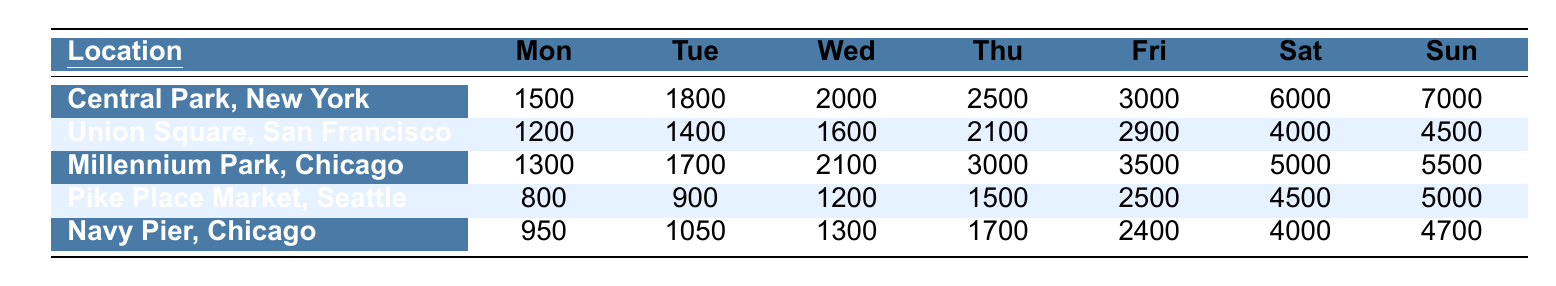What is the pedestrian traffic in Central Park on Saturday? The table shows that on Saturday, Central Park, New York has a pedestrian traffic of 6000.
Answer: 6000 Which location has the highest pedestrian traffic on Sunday? According to the table, Central Park, New York has the highest pedestrian traffic on Sunday with 7000.
Answer: Central Park, New York What is the average pedestrian traffic for Union Square, San Francisco during the week? To find the average, sum the daily values: 1200 + 1400 + 1600 + 2100 + 2900 + 4000 + 4500 = 19500. There are 7 days, so the average is 19500 / 7 = approximately 2786.
Answer: 2786 On which day does Pike Place Market, Seattle see the lowest pedestrian traffic? The table indicates that on Monday, Pike Place Market, Seattle has the lowest pedestrian traffic with only 800.
Answer: Monday What is the difference in pedestrian traffic between Millennium Park on Friday and Saturday? Millennium Park has 3500 on Friday and 5000 on Saturday. The difference is 5000 - 3500 = 1500.
Answer: 1500 Does Navy Pier, Chicago have higher pedestrian traffic on Sunday than Union Square, San Francisco on Friday? Navy Pier has 4700 on Sunday and Union Square has 2900 on Friday. Since 4700 > 2900, the statement is true.
Answer: Yes What is the total pedestrian traffic for all locations on Thursday? The total traffic on Thursday is: 2500 (Central Park) + 2100 (Union Square) + 3000 (Millennium Park) + 1500 (Pike Place Market) + 1700 (Navy Pier) = 10800.
Answer: 10800 Which weekday has the highest pedestrian traffic overall across all locations? Examining the table data, Friday has the highest traffic with 3000 (Central Park) + 2900 (Union Square) + 3500 (Millennium Park) + 2500 (Pike Place Market) + 2400 (Navy Pier) = 16300.
Answer: Friday What is the ratio of pedestrian traffic in Central Park on Sunday to that in Pike Place Market on Wednesday? Central Park's traffic on Sunday is 7000 and Pike Place Market's on Wednesday is 1200. The ratio is 7000:1200, which simplifies to 35:6.
Answer: 35:6 Is the average pedestrian traffic across all centers on Saturday greater than 5000? The average can be calculated: (6000 + 4000 + 5000 + 4500 + 4000) / 5 = 4600. Since 4600 < 5000, the statement is false.
Answer: No 